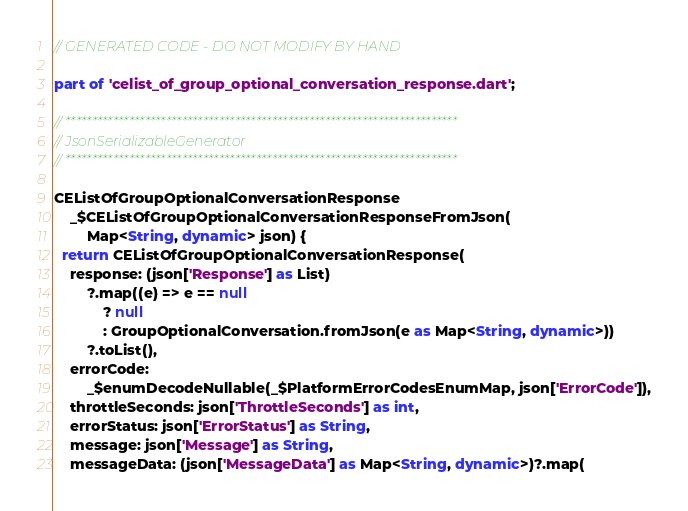Convert code to text. <code><loc_0><loc_0><loc_500><loc_500><_Dart_>// GENERATED CODE - DO NOT MODIFY BY HAND

part of 'celist_of_group_optional_conversation_response.dart';

// **************************************************************************
// JsonSerializableGenerator
// **************************************************************************

CEListOfGroupOptionalConversationResponse
    _$CEListOfGroupOptionalConversationResponseFromJson(
        Map<String, dynamic> json) {
  return CEListOfGroupOptionalConversationResponse(
    response: (json['Response'] as List)
        ?.map((e) => e == null
            ? null
            : GroupOptionalConversation.fromJson(e as Map<String, dynamic>))
        ?.toList(),
    errorCode:
        _$enumDecodeNullable(_$PlatformErrorCodesEnumMap, json['ErrorCode']),
    throttleSeconds: json['ThrottleSeconds'] as int,
    errorStatus: json['ErrorStatus'] as String,
    message: json['Message'] as String,
    messageData: (json['MessageData'] as Map<String, dynamic>)?.map(</code> 